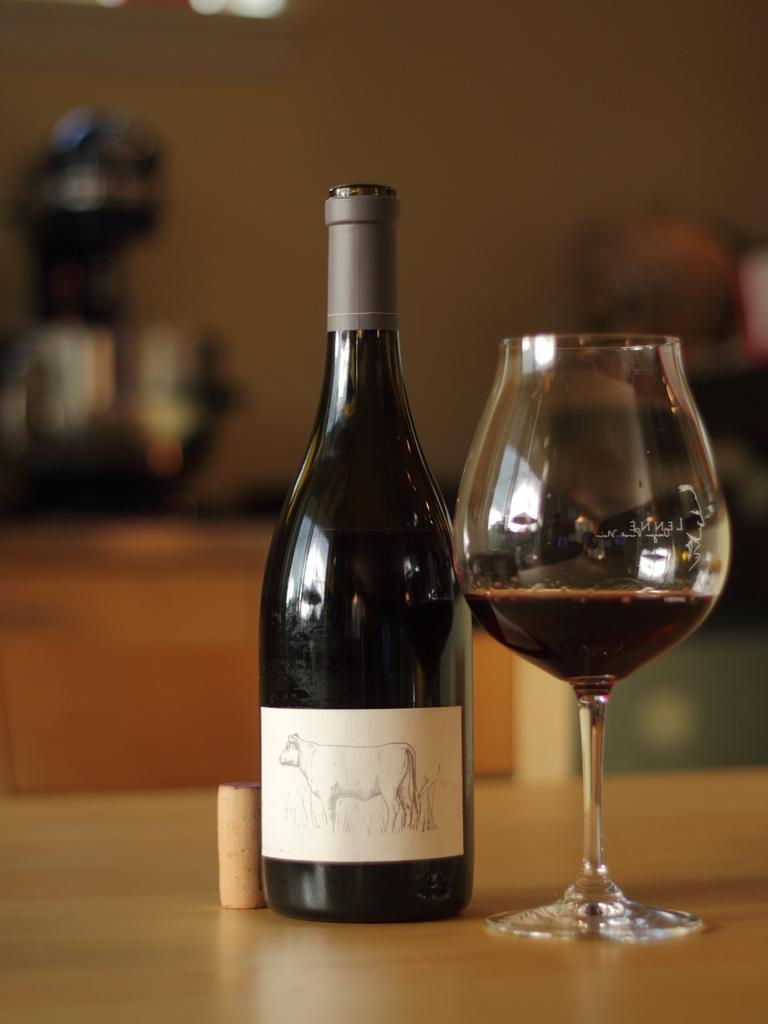Can you describe this image briefly? This is a wine bottle and a glass are kept on this wooden table. 